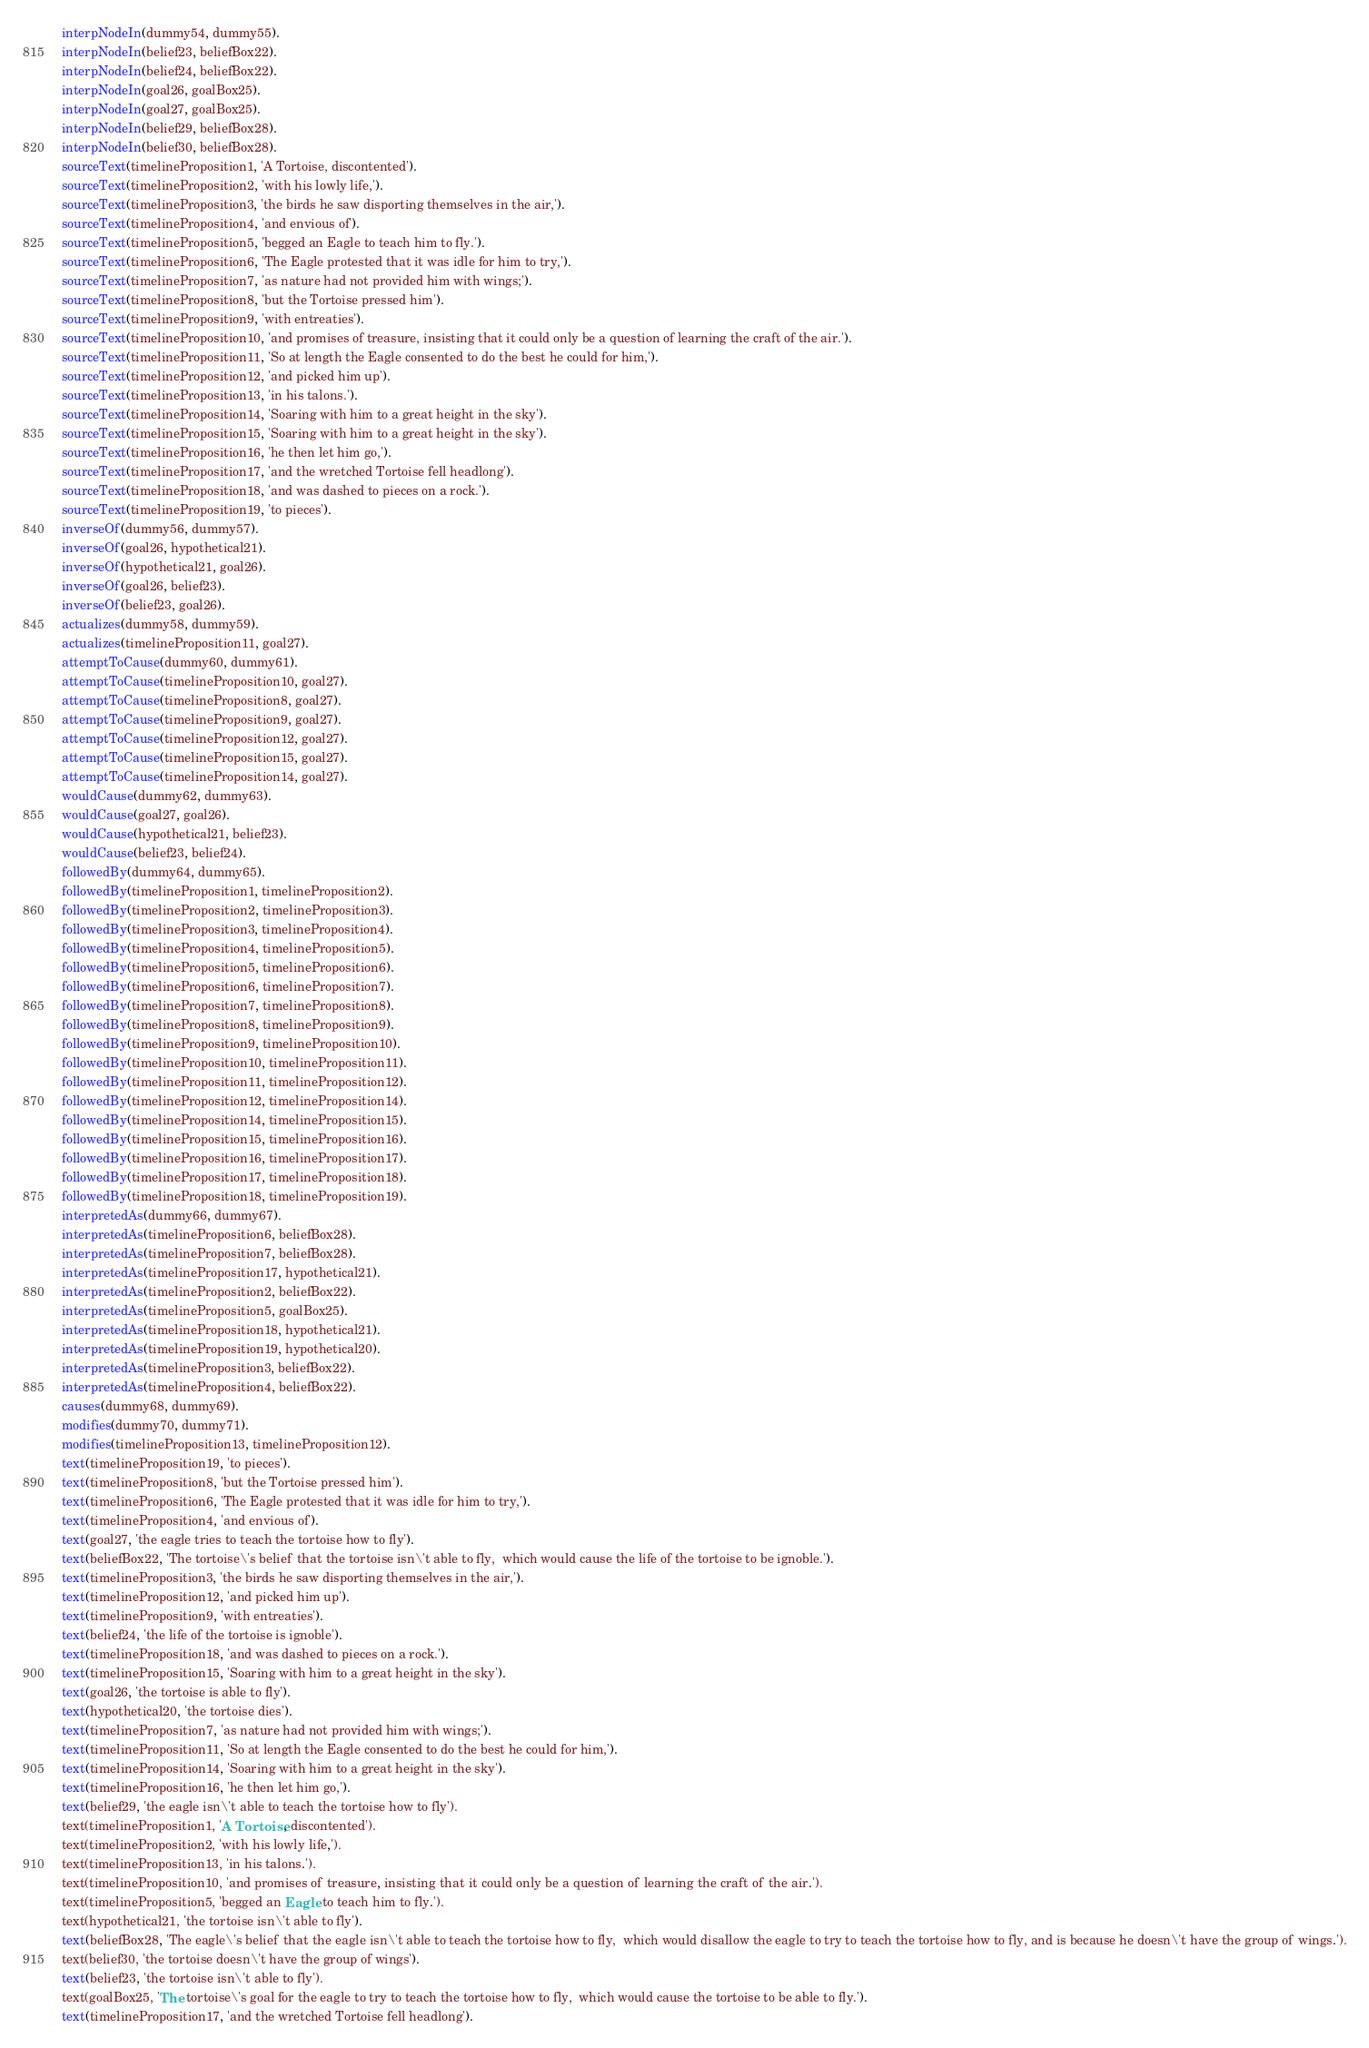<code> <loc_0><loc_0><loc_500><loc_500><_Prolog_>interpNodeIn(dummy54, dummy55).
interpNodeIn(belief23, beliefBox22).
interpNodeIn(belief24, beliefBox22).
interpNodeIn(goal26, goalBox25).
interpNodeIn(goal27, goalBox25).
interpNodeIn(belief29, beliefBox28).
interpNodeIn(belief30, beliefBox28).
sourceText(timelineProposition1, 'A Tortoise, discontented').
sourceText(timelineProposition2, 'with his lowly life,').
sourceText(timelineProposition3, 'the birds he saw disporting themselves in the air,').
sourceText(timelineProposition4, 'and envious of').
sourceText(timelineProposition5, 'begged an Eagle to teach him to fly.').
sourceText(timelineProposition6, 'The Eagle protested that it was idle for him to try,').
sourceText(timelineProposition7, 'as nature had not provided him with wings;').
sourceText(timelineProposition8, 'but the Tortoise pressed him').
sourceText(timelineProposition9, 'with entreaties').
sourceText(timelineProposition10, 'and promises of treasure, insisting that it could only be a question of learning the craft of the air.').
sourceText(timelineProposition11, 'So at length the Eagle consented to do the best he could for him,').
sourceText(timelineProposition12, 'and picked him up').
sourceText(timelineProposition13, 'in his talons.').
sourceText(timelineProposition14, 'Soaring with him to a great height in the sky').
sourceText(timelineProposition15, 'Soaring with him to a great height in the sky').
sourceText(timelineProposition16, 'he then let him go,').
sourceText(timelineProposition17, 'and the wretched Tortoise fell headlong').
sourceText(timelineProposition18, 'and was dashed to pieces on a rock.').
sourceText(timelineProposition19, 'to pieces').
inverseOf(dummy56, dummy57).
inverseOf(goal26, hypothetical21).
inverseOf(hypothetical21, goal26).
inverseOf(goal26, belief23).
inverseOf(belief23, goal26).
actualizes(dummy58, dummy59).
actualizes(timelineProposition11, goal27).
attemptToCause(dummy60, dummy61).
attemptToCause(timelineProposition10, goal27).
attemptToCause(timelineProposition8, goal27).
attemptToCause(timelineProposition9, goal27).
attemptToCause(timelineProposition12, goal27).
attemptToCause(timelineProposition15, goal27).
attemptToCause(timelineProposition14, goal27).
wouldCause(dummy62, dummy63).
wouldCause(goal27, goal26).
wouldCause(hypothetical21, belief23).
wouldCause(belief23, belief24).
followedBy(dummy64, dummy65).
followedBy(timelineProposition1, timelineProposition2).
followedBy(timelineProposition2, timelineProposition3).
followedBy(timelineProposition3, timelineProposition4).
followedBy(timelineProposition4, timelineProposition5).
followedBy(timelineProposition5, timelineProposition6).
followedBy(timelineProposition6, timelineProposition7).
followedBy(timelineProposition7, timelineProposition8).
followedBy(timelineProposition8, timelineProposition9).
followedBy(timelineProposition9, timelineProposition10).
followedBy(timelineProposition10, timelineProposition11).
followedBy(timelineProposition11, timelineProposition12).
followedBy(timelineProposition12, timelineProposition14).
followedBy(timelineProposition14, timelineProposition15).
followedBy(timelineProposition15, timelineProposition16).
followedBy(timelineProposition16, timelineProposition17).
followedBy(timelineProposition17, timelineProposition18).
followedBy(timelineProposition18, timelineProposition19).
interpretedAs(dummy66, dummy67).
interpretedAs(timelineProposition6, beliefBox28).
interpretedAs(timelineProposition7, beliefBox28).
interpretedAs(timelineProposition17, hypothetical21).
interpretedAs(timelineProposition2, beliefBox22).
interpretedAs(timelineProposition5, goalBox25).
interpretedAs(timelineProposition18, hypothetical21).
interpretedAs(timelineProposition19, hypothetical20).
interpretedAs(timelineProposition3, beliefBox22).
interpretedAs(timelineProposition4, beliefBox22).
causes(dummy68, dummy69).
modifies(dummy70, dummy71).
modifies(timelineProposition13, timelineProposition12).
text(timelineProposition19, 'to pieces').
text(timelineProposition8, 'but the Tortoise pressed him').
text(timelineProposition6, 'The Eagle protested that it was idle for him to try,').
text(timelineProposition4, 'and envious of').
text(goal27, 'the eagle tries to teach the tortoise how to fly').
text(beliefBox22, 'The tortoise\'s belief that the tortoise isn\'t able to fly,  which would cause the life of the tortoise to be ignoble.').
text(timelineProposition3, 'the birds he saw disporting themselves in the air,').
text(timelineProposition12, 'and picked him up').
text(timelineProposition9, 'with entreaties').
text(belief24, 'the life of the tortoise is ignoble').
text(timelineProposition18, 'and was dashed to pieces on a rock.').
text(timelineProposition15, 'Soaring with him to a great height in the sky').
text(goal26, 'the tortoise is able to fly').
text(hypothetical20, 'the tortoise dies').
text(timelineProposition7, 'as nature had not provided him with wings;').
text(timelineProposition11, 'So at length the Eagle consented to do the best he could for him,').
text(timelineProposition14, 'Soaring with him to a great height in the sky').
text(timelineProposition16, 'he then let him go,').
text(belief29, 'the eagle isn\'t able to teach the tortoise how to fly').
text(timelineProposition1, 'A Tortoise, discontented').
text(timelineProposition2, 'with his lowly life,').
text(timelineProposition13, 'in his talons.').
text(timelineProposition10, 'and promises of treasure, insisting that it could only be a question of learning the craft of the air.').
text(timelineProposition5, 'begged an Eagle to teach him to fly.').
text(hypothetical21, 'the tortoise isn\'t able to fly').
text(beliefBox28, 'The eagle\'s belief that the eagle isn\'t able to teach the tortoise how to fly,  which would disallow the eagle to try to teach the tortoise how to fly, and is because he doesn\'t have the group of wings.').
text(belief30, 'the tortoise doesn\'t have the group of wings').
text(belief23, 'the tortoise isn\'t able to fly').
text(goalBox25, 'The tortoise\'s goal for the eagle to try to teach the tortoise how to fly,  which would cause the tortoise to be able to fly.').
text(timelineProposition17, 'and the wretched Tortoise fell headlong').

</code> 